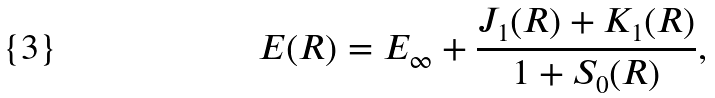Convert formula to latex. <formula><loc_0><loc_0><loc_500><loc_500>E ( R ) = E _ { \infty } + \frac { J _ { 1 } ( R ) + K _ { 1 } ( R ) } { 1 + S _ { 0 } ( R ) } ,</formula> 